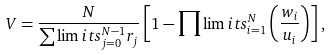Convert formula to latex. <formula><loc_0><loc_0><loc_500><loc_500>V = \frac { N } { \sum \lim i t s _ { j = 0 } ^ { N - 1 } r _ { j } } \left [ 1 - \prod \lim i t s _ { i = 1 } ^ { N } \left ( \frac { w _ { i } } { u _ { i } } \right ) \right ] ,</formula> 